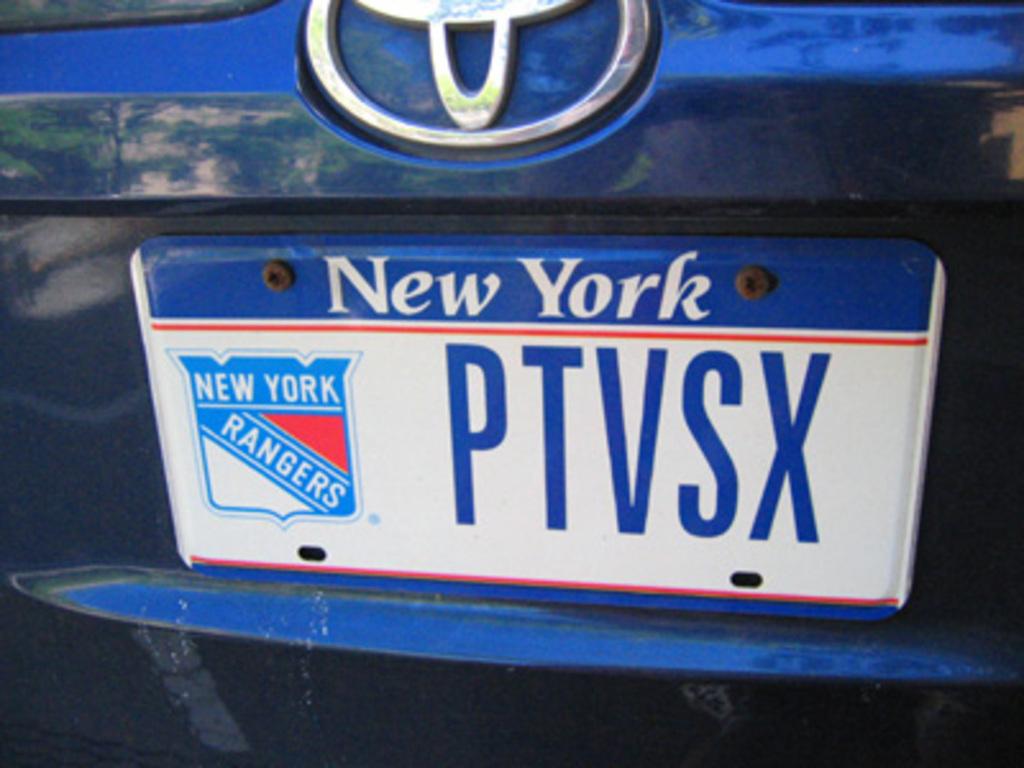From what state is this license plate?
Your response must be concise. New york. What team is that?
Give a very brief answer. Rangers. 